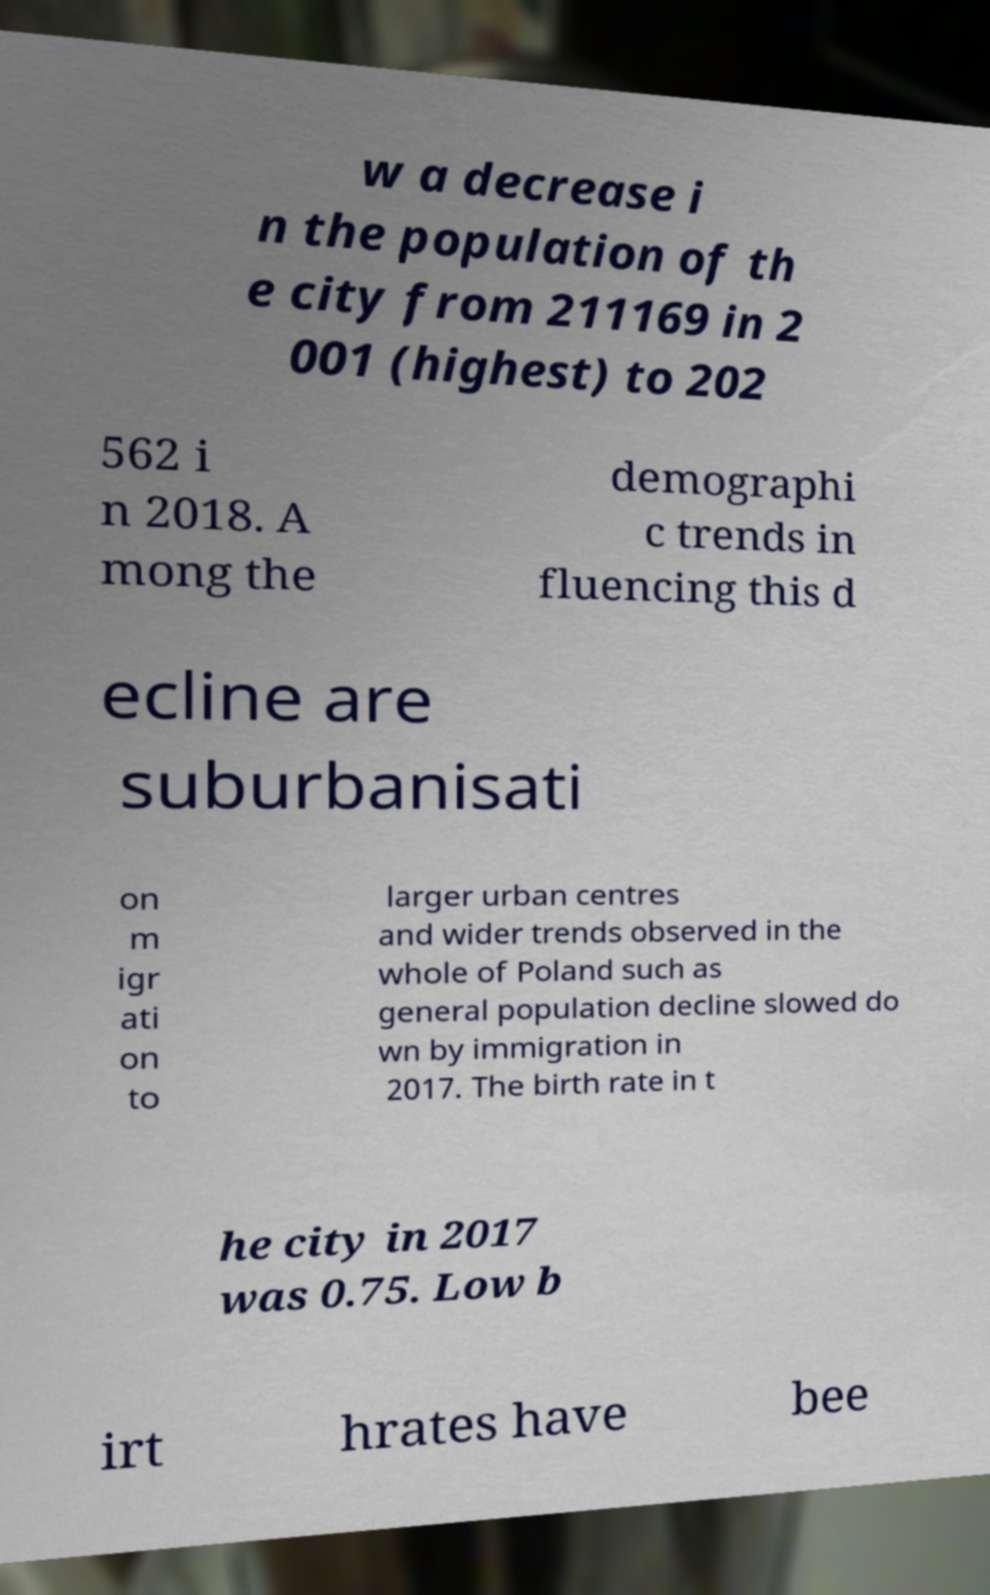Can you read and provide the text displayed in the image?This photo seems to have some interesting text. Can you extract and type it out for me? w a decrease i n the population of th e city from 211169 in 2 001 (highest) to 202 562 i n 2018. A mong the demographi c trends in fluencing this d ecline are suburbanisati on m igr ati on to larger urban centres and wider trends observed in the whole of Poland such as general population decline slowed do wn by immigration in 2017. The birth rate in t he city in 2017 was 0.75. Low b irt hrates have bee 